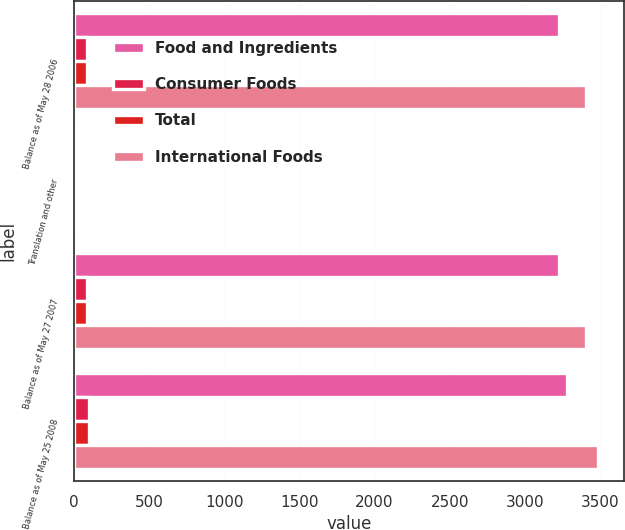Convert chart to OTSL. <chart><loc_0><loc_0><loc_500><loc_500><stacked_bar_chart><ecel><fcel>Balance as of May 28 2006<fcel>Translation and other<fcel>Balance as of May 27 2007<fcel>Balance as of May 25 2008<nl><fcel>Food and Ingredients<fcel>3229.3<fcel>0.9<fcel>3228.4<fcel>3281.6<nl><fcel>Consumer Foods<fcel>84.8<fcel>0.6<fcel>85.1<fcel>102.8<nl><fcel>Total<fcel>89.4<fcel>1.9<fcel>91.3<fcel>98.9<nl><fcel>International Foods<fcel>3403.5<fcel>1.6<fcel>3404.8<fcel>3483.3<nl></chart> 